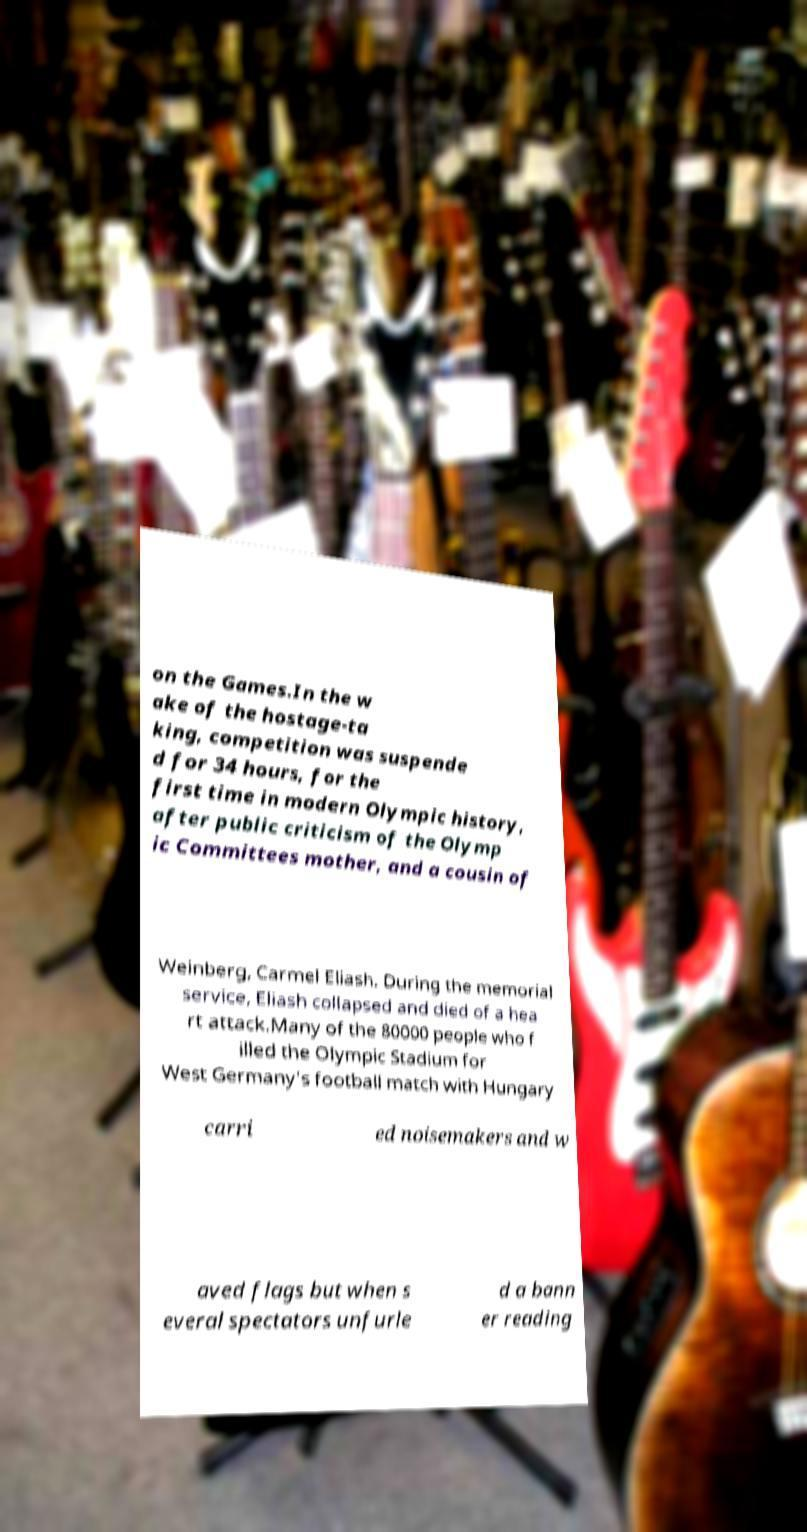Can you read and provide the text displayed in the image?This photo seems to have some interesting text. Can you extract and type it out for me? on the Games.In the w ake of the hostage-ta king, competition was suspende d for 34 hours, for the first time in modern Olympic history, after public criticism of the Olymp ic Committees mother, and a cousin of Weinberg, Carmel Eliash. During the memorial service, Eliash collapsed and died of a hea rt attack.Many of the 80000 people who f illed the Olympic Stadium for West Germany's football match with Hungary carri ed noisemakers and w aved flags but when s everal spectators unfurle d a bann er reading 